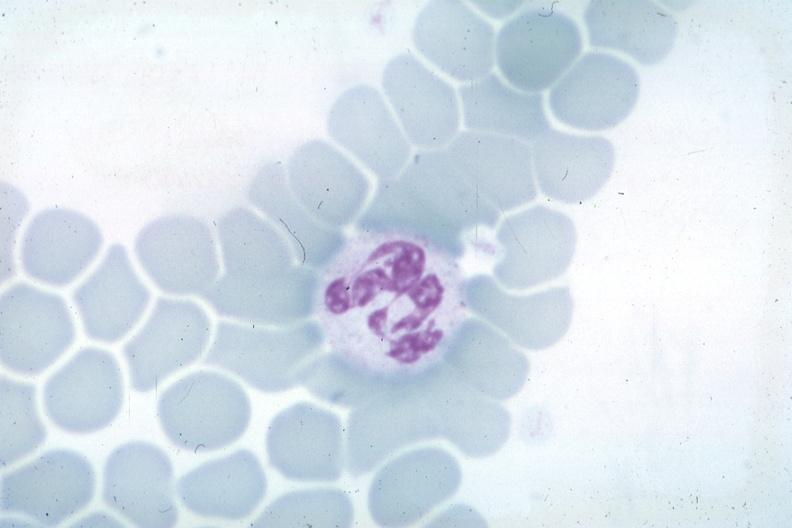s nuclear change obvious source unknown?
Answer the question using a single word or phrase. Yes 